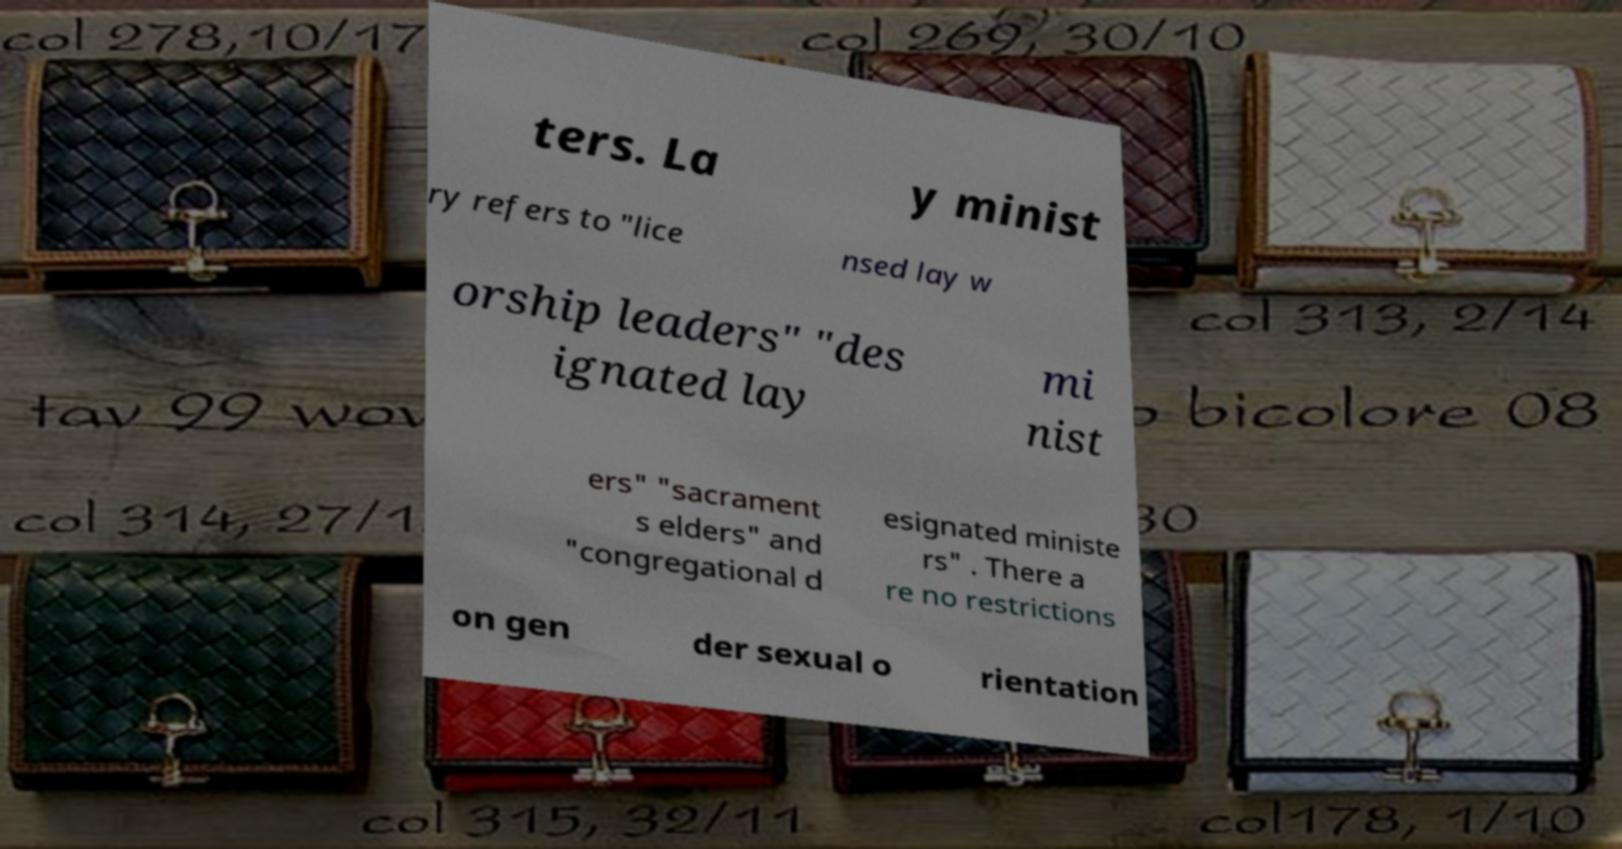Could you assist in decoding the text presented in this image and type it out clearly? ters. La y minist ry refers to "lice nsed lay w orship leaders" "des ignated lay mi nist ers" "sacrament s elders" and "congregational d esignated ministe rs" . There a re no restrictions on gen der sexual o rientation 